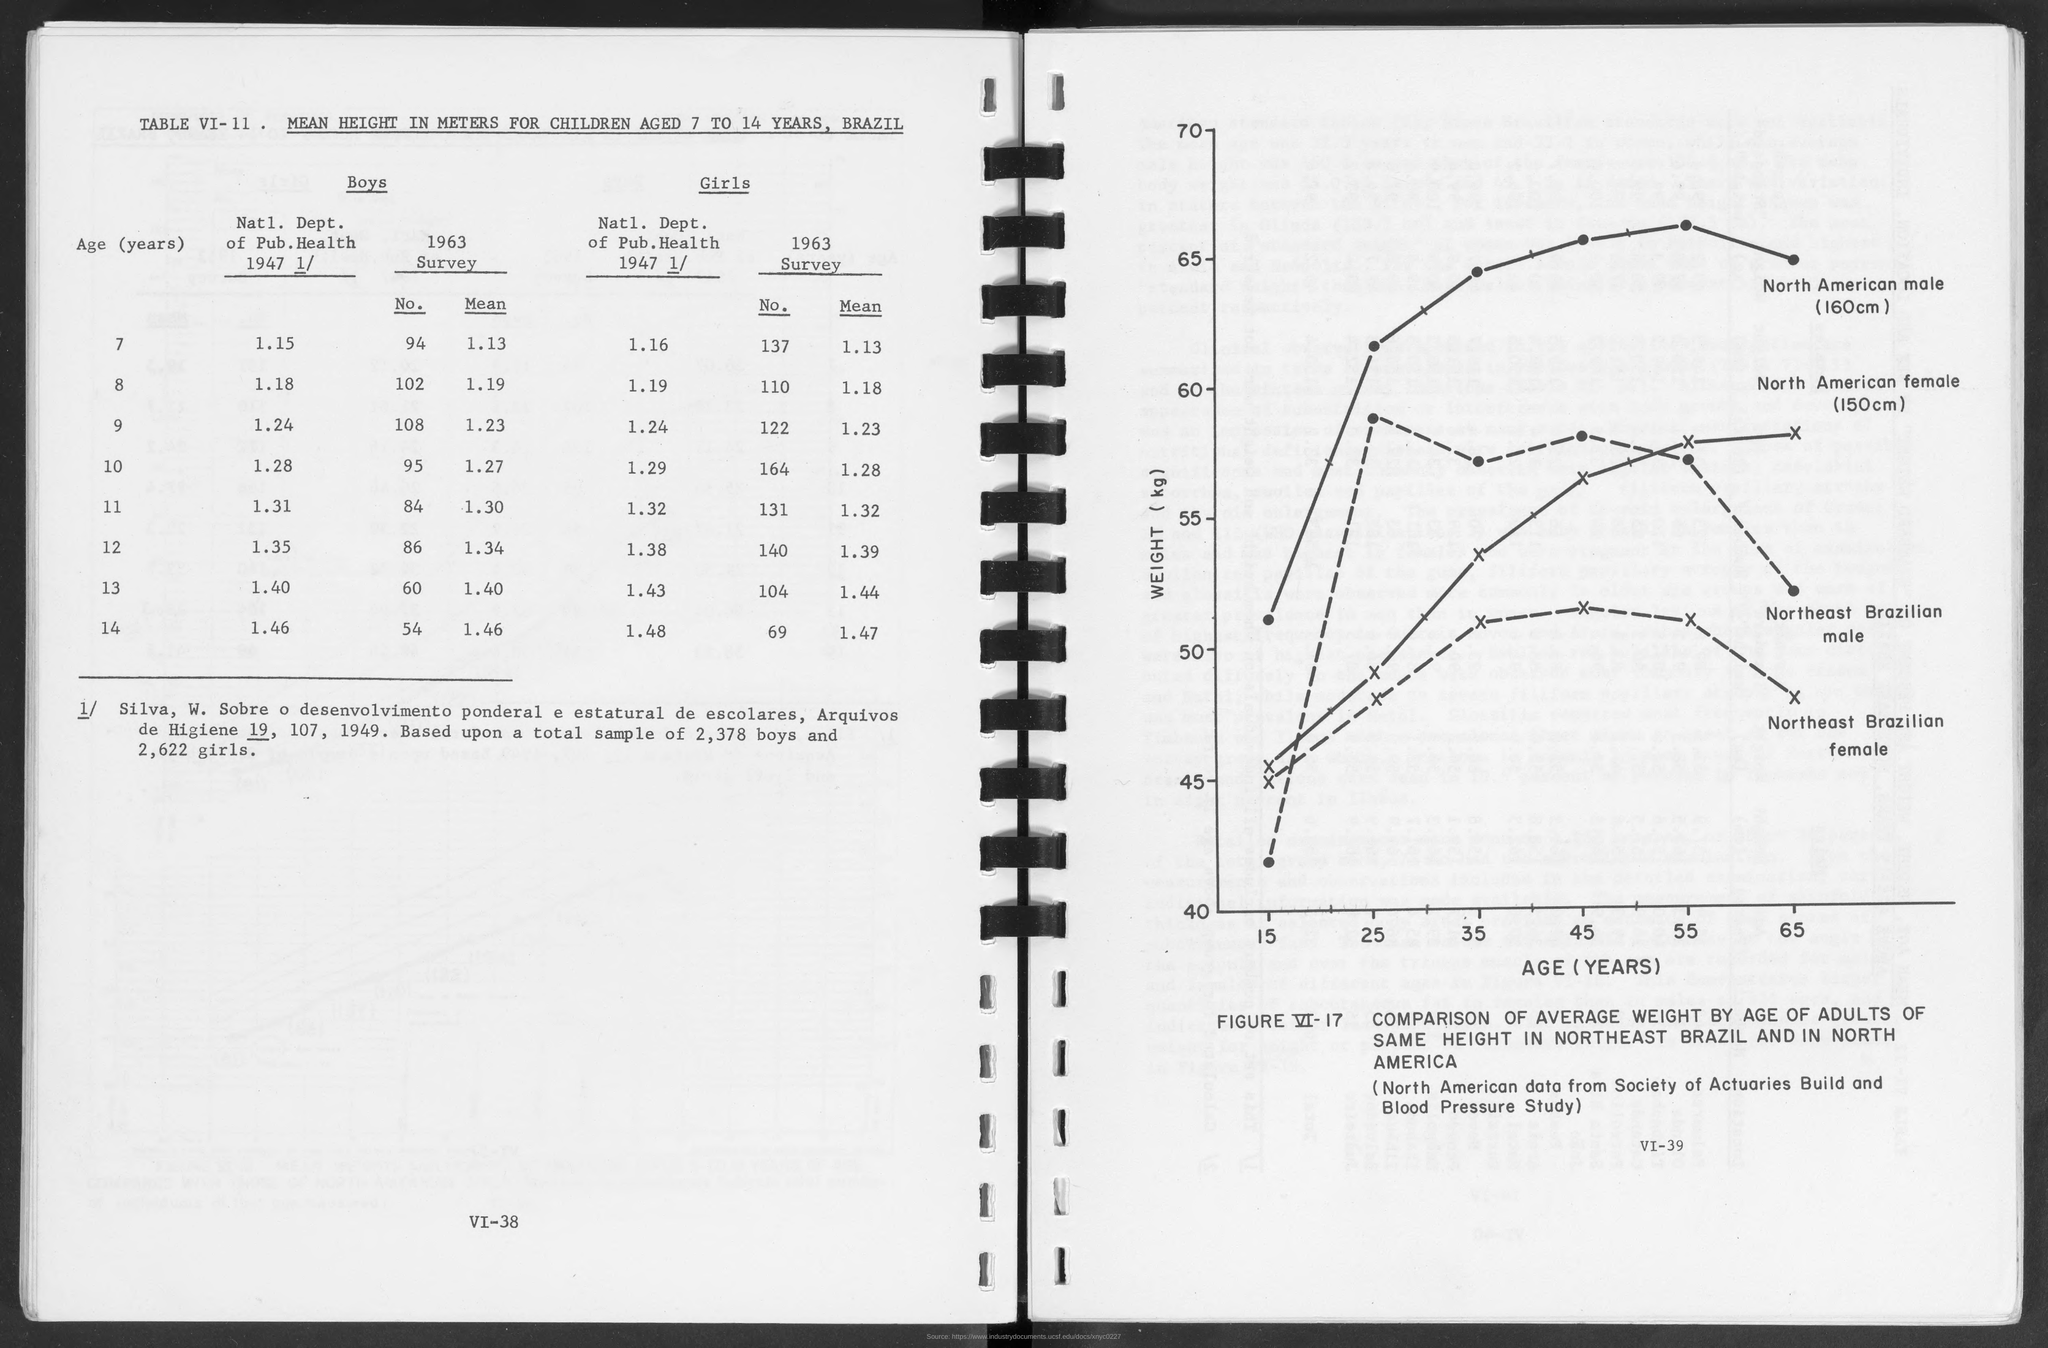What is the title of table VI-11?
Provide a short and direct response. Mean height in meters for children aged 7 to 14 years, brazil. On how many boys were the total sample based?
Provide a short and direct response. 2,378. What is the variable on X axis of the graph in FIGURE VI-17?
Offer a terse response. AGE. What is the variable on Y axis of the graph in FIGURE VI-17?
Give a very brief answer. Weight (kg). From where is the North American Data taken from?
Offer a very short reply. Society of Actuaries Build and Blood Pressure Study. 